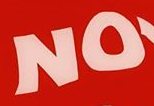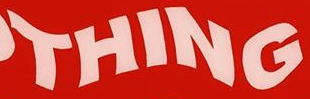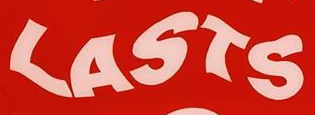What words are shown in these images in order, separated by a semicolon? NO; THING; LASTS 